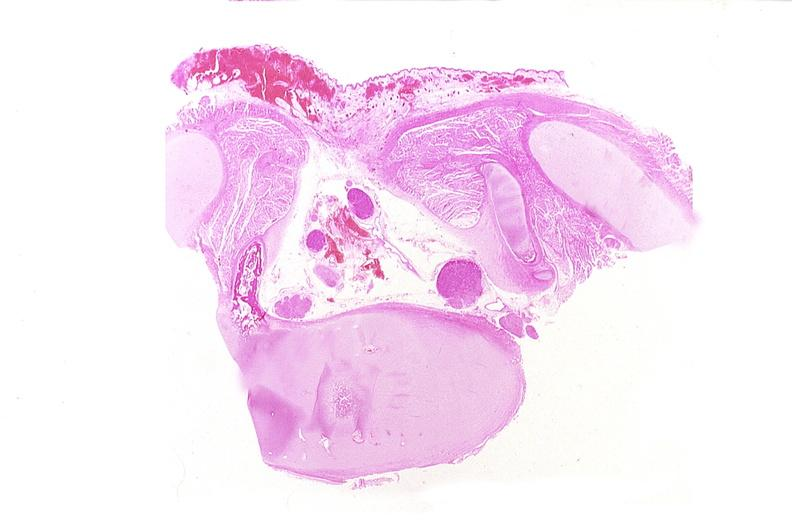what does this image show?
Answer the question using a single word or phrase. Neural tube defect 